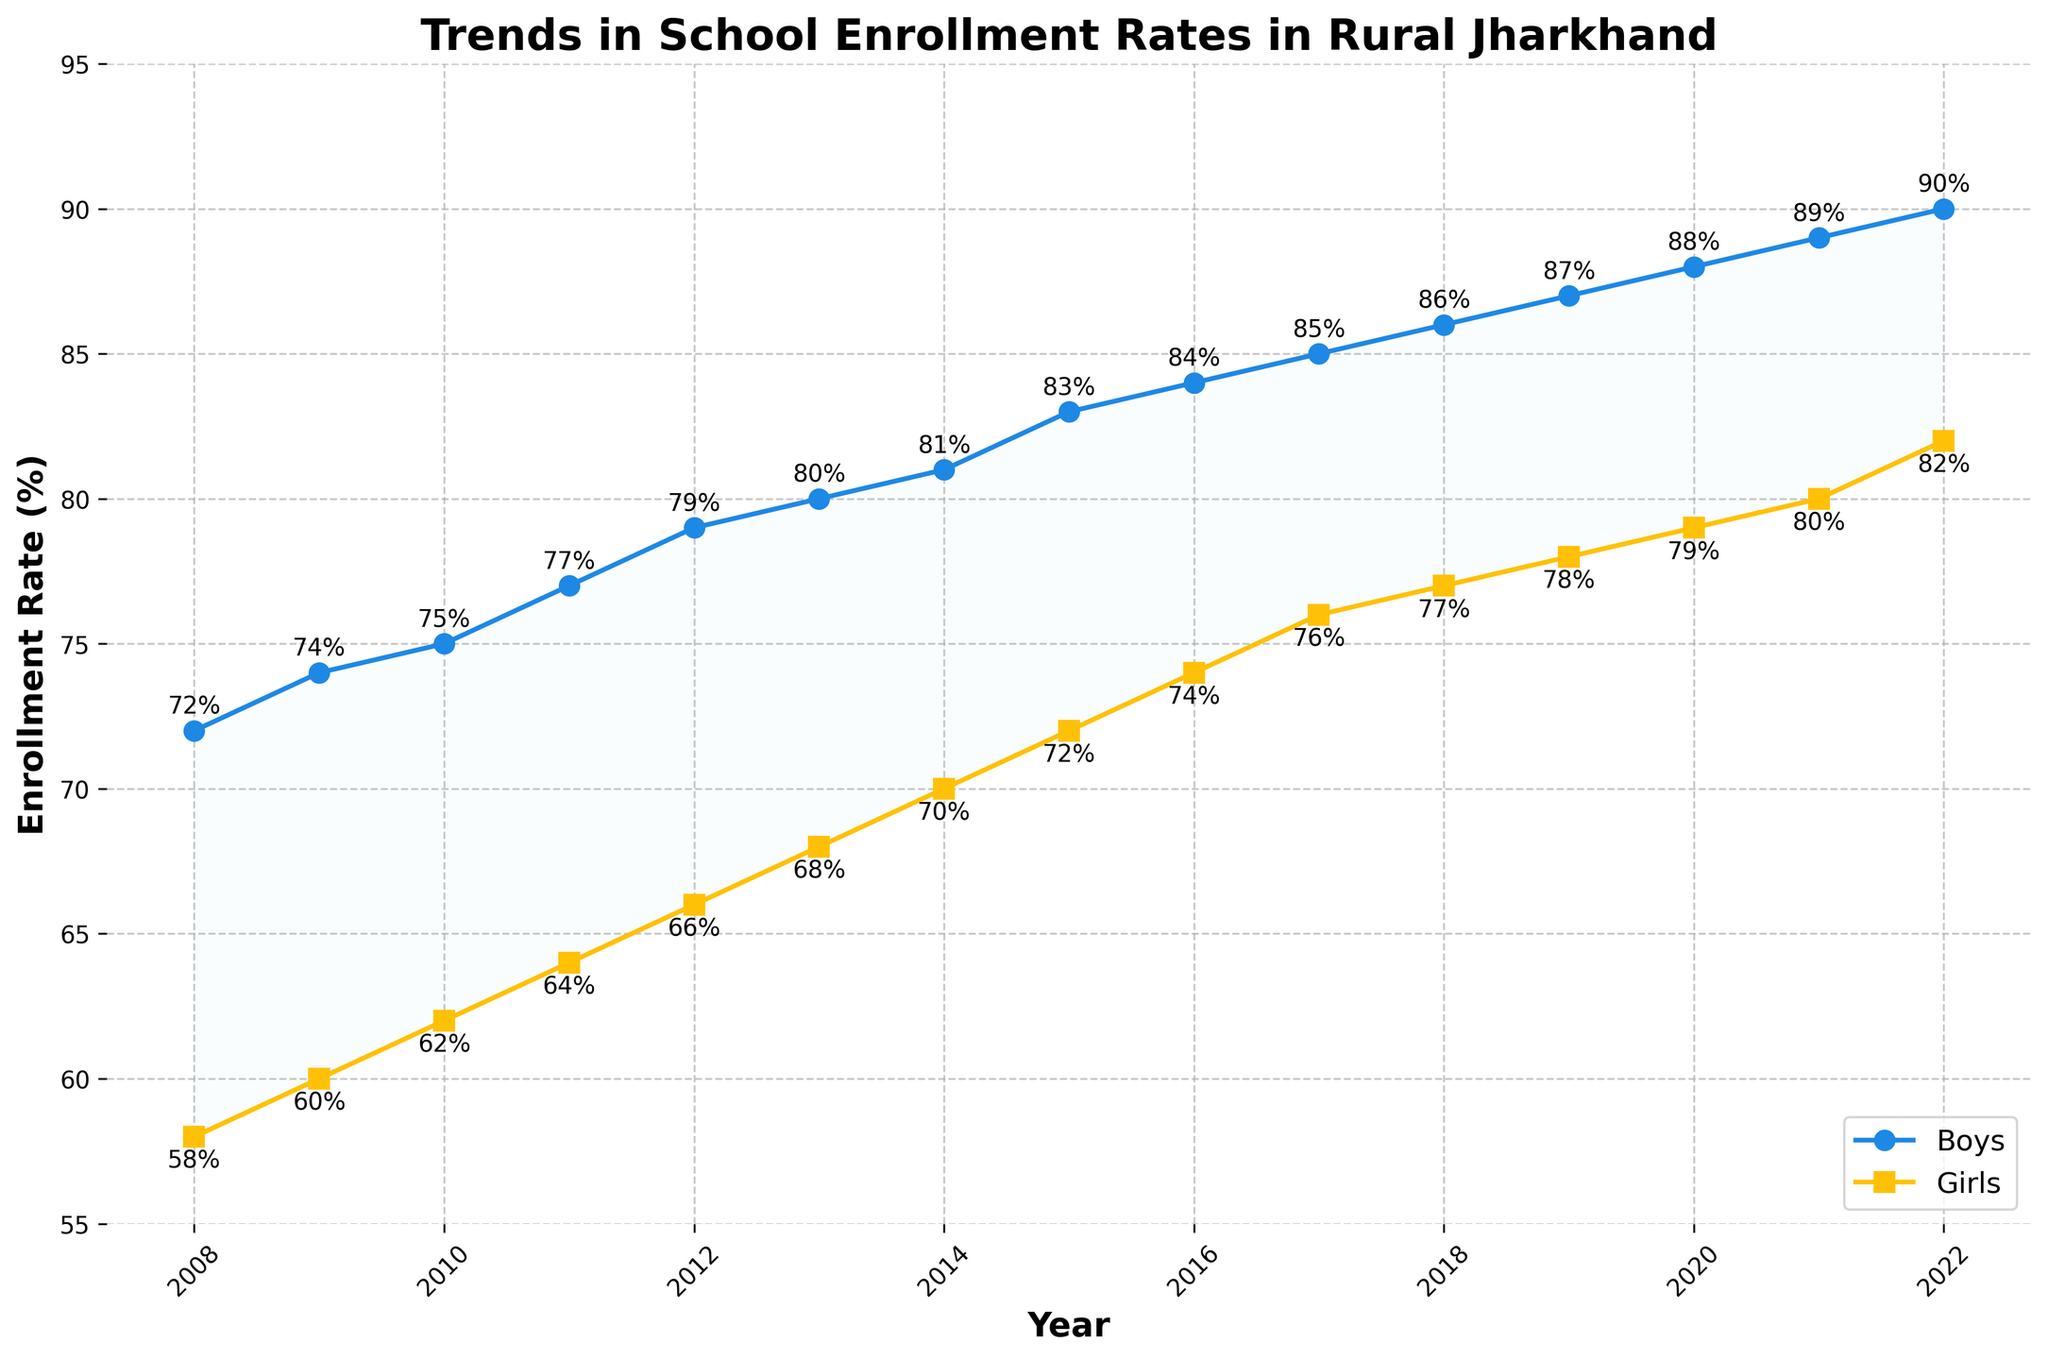What is the title of the plot? The title is displayed at the top of the figure and provides an overview of the data being presented.
Answer: Trends in School Enrollment Rates in Rural Jharkhand What is the enrollment rate for boys in 2022? Locate the data point for boys in the year 2022 along the plot.
Answer: 90% How does the enrollment rate for girls change from 2008 to 2022? Compare the first and last data points for girls to see the change over the years.
Answer: Increases from 58% to 82% Which gender had a higher enrollment rate in 2015? Compare the enrollment rates for boys and girls at the year 2015.
Answer: Boys How many years does the data span in the plot? Count the number of years from the first to the last year on the x-axis.
Answer: 15 years What is the difference in enrollment rates between boys and girls in 2018? Subtract the enrollment rate for girls from that of boys for the year 2018.
Answer: 9% What is the average enrollment rate for girls over the entire period? Sum the enrollment rates for girls from 2008 to 2022 and divide by the number of years (15).
Answer: 71% In which year did both boys and girls see the highest enrollment rates? Identify the year corresponding to the highest points of each trend line.
Answer: 2022 By how much did the enrollment rate for boys increase from 2010 to 2020? Subtract the 2010 value from the 2020 value for boys' enrollment.
Answer: 13% Does the gap between boys' and girls' enrollment rates widen or narrow from 2008 to 2022? Observe the space between the two lines for the starting and ending years.
Answer: Narrows 